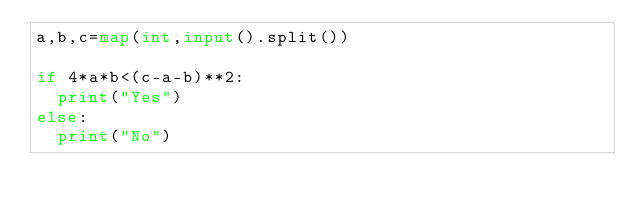<code> <loc_0><loc_0><loc_500><loc_500><_Python_>a,b,c=map(int,input().split())

if 4*a*b<(c-a-b)**2:
  print("Yes")
else:
  print("No")</code> 